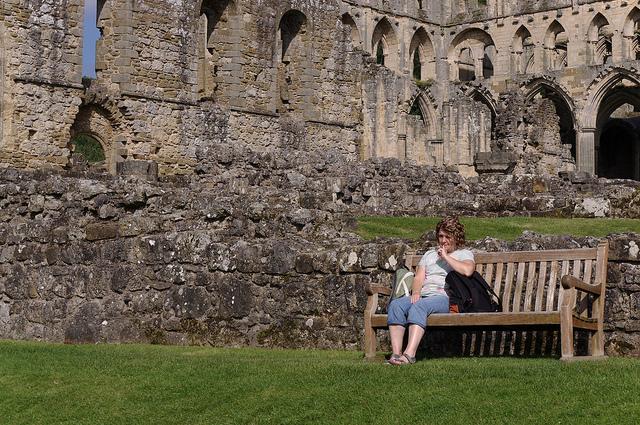Is this building old?
Be succinct. Yes. Is there a bench?
Concise answer only. Yes. Is the woman taking a break?
Give a very brief answer. Yes. 